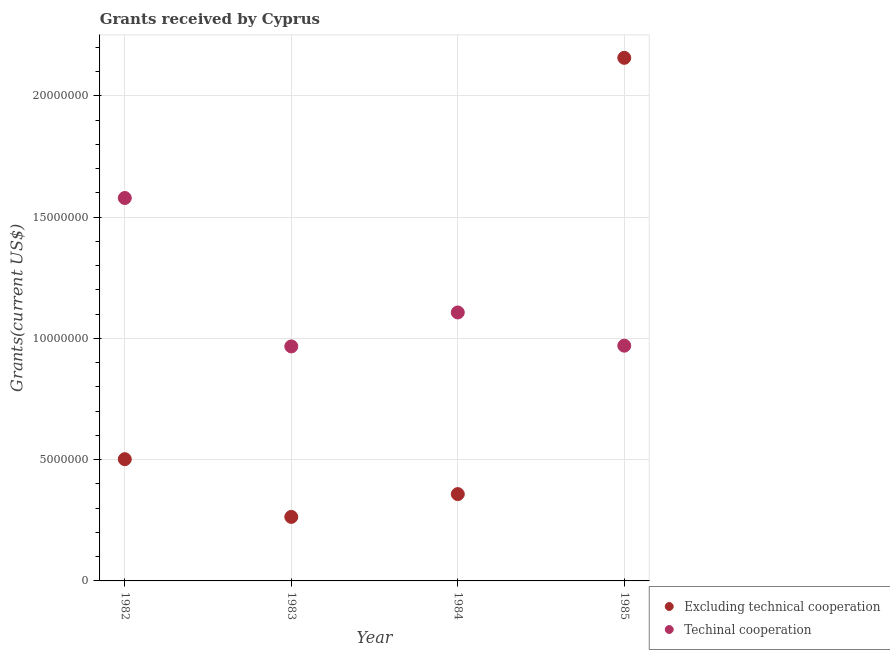What is the amount of grants received(excluding technical cooperation) in 1985?
Make the answer very short. 2.16e+07. Across all years, what is the maximum amount of grants received(excluding technical cooperation)?
Provide a succinct answer. 2.16e+07. Across all years, what is the minimum amount of grants received(including technical cooperation)?
Provide a succinct answer. 9.67e+06. In which year was the amount of grants received(excluding technical cooperation) minimum?
Provide a short and direct response. 1983. What is the total amount of grants received(including technical cooperation) in the graph?
Your response must be concise. 4.62e+07. What is the difference between the amount of grants received(excluding technical cooperation) in 1984 and that in 1985?
Ensure brevity in your answer.  -1.80e+07. What is the difference between the amount of grants received(including technical cooperation) in 1985 and the amount of grants received(excluding technical cooperation) in 1984?
Offer a very short reply. 6.12e+06. What is the average amount of grants received(excluding technical cooperation) per year?
Ensure brevity in your answer.  8.20e+06. In the year 1982, what is the difference between the amount of grants received(including technical cooperation) and amount of grants received(excluding technical cooperation)?
Your answer should be compact. 1.08e+07. In how many years, is the amount of grants received(excluding technical cooperation) greater than 14000000 US$?
Offer a very short reply. 1. What is the ratio of the amount of grants received(excluding technical cooperation) in 1983 to that in 1984?
Provide a short and direct response. 0.74. Is the amount of grants received(excluding technical cooperation) in 1982 less than that in 1984?
Your response must be concise. No. What is the difference between the highest and the second highest amount of grants received(excluding technical cooperation)?
Your response must be concise. 1.66e+07. What is the difference between the highest and the lowest amount of grants received(excluding technical cooperation)?
Give a very brief answer. 1.89e+07. In how many years, is the amount of grants received(excluding technical cooperation) greater than the average amount of grants received(excluding technical cooperation) taken over all years?
Your answer should be compact. 1. Is the sum of the amount of grants received(excluding technical cooperation) in 1982 and 1983 greater than the maximum amount of grants received(including technical cooperation) across all years?
Your answer should be compact. No. Does the amount of grants received(excluding technical cooperation) monotonically increase over the years?
Your answer should be very brief. No. Is the amount of grants received(excluding technical cooperation) strictly less than the amount of grants received(including technical cooperation) over the years?
Provide a succinct answer. No. How many dotlines are there?
Keep it short and to the point. 2. How many years are there in the graph?
Ensure brevity in your answer.  4. Are the values on the major ticks of Y-axis written in scientific E-notation?
Your answer should be compact. No. Where does the legend appear in the graph?
Offer a very short reply. Bottom right. How many legend labels are there?
Your response must be concise. 2. How are the legend labels stacked?
Ensure brevity in your answer.  Vertical. What is the title of the graph?
Make the answer very short. Grants received by Cyprus. Does "From production" appear as one of the legend labels in the graph?
Ensure brevity in your answer.  No. What is the label or title of the X-axis?
Make the answer very short. Year. What is the label or title of the Y-axis?
Make the answer very short. Grants(current US$). What is the Grants(current US$) in Excluding technical cooperation in 1982?
Keep it short and to the point. 5.02e+06. What is the Grants(current US$) in Techinal cooperation in 1982?
Give a very brief answer. 1.58e+07. What is the Grants(current US$) in Excluding technical cooperation in 1983?
Your response must be concise. 2.64e+06. What is the Grants(current US$) of Techinal cooperation in 1983?
Your response must be concise. 9.67e+06. What is the Grants(current US$) of Excluding technical cooperation in 1984?
Keep it short and to the point. 3.58e+06. What is the Grants(current US$) of Techinal cooperation in 1984?
Ensure brevity in your answer.  1.11e+07. What is the Grants(current US$) in Excluding technical cooperation in 1985?
Your answer should be very brief. 2.16e+07. What is the Grants(current US$) in Techinal cooperation in 1985?
Offer a very short reply. 9.70e+06. Across all years, what is the maximum Grants(current US$) in Excluding technical cooperation?
Provide a succinct answer. 2.16e+07. Across all years, what is the maximum Grants(current US$) of Techinal cooperation?
Provide a succinct answer. 1.58e+07. Across all years, what is the minimum Grants(current US$) of Excluding technical cooperation?
Your response must be concise. 2.64e+06. Across all years, what is the minimum Grants(current US$) of Techinal cooperation?
Give a very brief answer. 9.67e+06. What is the total Grants(current US$) of Excluding technical cooperation in the graph?
Your answer should be very brief. 3.28e+07. What is the total Grants(current US$) in Techinal cooperation in the graph?
Make the answer very short. 4.62e+07. What is the difference between the Grants(current US$) of Excluding technical cooperation in 1982 and that in 1983?
Provide a short and direct response. 2.38e+06. What is the difference between the Grants(current US$) of Techinal cooperation in 1982 and that in 1983?
Offer a terse response. 6.12e+06. What is the difference between the Grants(current US$) in Excluding technical cooperation in 1982 and that in 1984?
Your answer should be very brief. 1.44e+06. What is the difference between the Grants(current US$) in Techinal cooperation in 1982 and that in 1984?
Your response must be concise. 4.72e+06. What is the difference between the Grants(current US$) of Excluding technical cooperation in 1982 and that in 1985?
Ensure brevity in your answer.  -1.66e+07. What is the difference between the Grants(current US$) in Techinal cooperation in 1982 and that in 1985?
Your answer should be compact. 6.09e+06. What is the difference between the Grants(current US$) in Excluding technical cooperation in 1983 and that in 1984?
Offer a terse response. -9.40e+05. What is the difference between the Grants(current US$) in Techinal cooperation in 1983 and that in 1984?
Give a very brief answer. -1.40e+06. What is the difference between the Grants(current US$) of Excluding technical cooperation in 1983 and that in 1985?
Give a very brief answer. -1.89e+07. What is the difference between the Grants(current US$) of Excluding technical cooperation in 1984 and that in 1985?
Make the answer very short. -1.80e+07. What is the difference between the Grants(current US$) of Techinal cooperation in 1984 and that in 1985?
Keep it short and to the point. 1.37e+06. What is the difference between the Grants(current US$) of Excluding technical cooperation in 1982 and the Grants(current US$) of Techinal cooperation in 1983?
Offer a terse response. -4.65e+06. What is the difference between the Grants(current US$) in Excluding technical cooperation in 1982 and the Grants(current US$) in Techinal cooperation in 1984?
Your response must be concise. -6.05e+06. What is the difference between the Grants(current US$) of Excluding technical cooperation in 1982 and the Grants(current US$) of Techinal cooperation in 1985?
Offer a terse response. -4.68e+06. What is the difference between the Grants(current US$) of Excluding technical cooperation in 1983 and the Grants(current US$) of Techinal cooperation in 1984?
Keep it short and to the point. -8.43e+06. What is the difference between the Grants(current US$) in Excluding technical cooperation in 1983 and the Grants(current US$) in Techinal cooperation in 1985?
Make the answer very short. -7.06e+06. What is the difference between the Grants(current US$) of Excluding technical cooperation in 1984 and the Grants(current US$) of Techinal cooperation in 1985?
Your answer should be very brief. -6.12e+06. What is the average Grants(current US$) in Excluding technical cooperation per year?
Your answer should be compact. 8.20e+06. What is the average Grants(current US$) of Techinal cooperation per year?
Keep it short and to the point. 1.16e+07. In the year 1982, what is the difference between the Grants(current US$) of Excluding technical cooperation and Grants(current US$) of Techinal cooperation?
Provide a short and direct response. -1.08e+07. In the year 1983, what is the difference between the Grants(current US$) of Excluding technical cooperation and Grants(current US$) of Techinal cooperation?
Provide a succinct answer. -7.03e+06. In the year 1984, what is the difference between the Grants(current US$) of Excluding technical cooperation and Grants(current US$) of Techinal cooperation?
Provide a short and direct response. -7.49e+06. In the year 1985, what is the difference between the Grants(current US$) of Excluding technical cooperation and Grants(current US$) of Techinal cooperation?
Offer a terse response. 1.19e+07. What is the ratio of the Grants(current US$) of Excluding technical cooperation in 1982 to that in 1983?
Your response must be concise. 1.9. What is the ratio of the Grants(current US$) in Techinal cooperation in 1982 to that in 1983?
Offer a very short reply. 1.63. What is the ratio of the Grants(current US$) of Excluding technical cooperation in 1982 to that in 1984?
Your answer should be compact. 1.4. What is the ratio of the Grants(current US$) of Techinal cooperation in 1982 to that in 1984?
Your answer should be very brief. 1.43. What is the ratio of the Grants(current US$) of Excluding technical cooperation in 1982 to that in 1985?
Provide a short and direct response. 0.23. What is the ratio of the Grants(current US$) of Techinal cooperation in 1982 to that in 1985?
Offer a very short reply. 1.63. What is the ratio of the Grants(current US$) in Excluding technical cooperation in 1983 to that in 1984?
Ensure brevity in your answer.  0.74. What is the ratio of the Grants(current US$) in Techinal cooperation in 1983 to that in 1984?
Ensure brevity in your answer.  0.87. What is the ratio of the Grants(current US$) in Excluding technical cooperation in 1983 to that in 1985?
Keep it short and to the point. 0.12. What is the ratio of the Grants(current US$) of Techinal cooperation in 1983 to that in 1985?
Offer a terse response. 1. What is the ratio of the Grants(current US$) in Excluding technical cooperation in 1984 to that in 1985?
Make the answer very short. 0.17. What is the ratio of the Grants(current US$) in Techinal cooperation in 1984 to that in 1985?
Offer a very short reply. 1.14. What is the difference between the highest and the second highest Grants(current US$) of Excluding technical cooperation?
Your answer should be very brief. 1.66e+07. What is the difference between the highest and the second highest Grants(current US$) in Techinal cooperation?
Offer a terse response. 4.72e+06. What is the difference between the highest and the lowest Grants(current US$) of Excluding technical cooperation?
Keep it short and to the point. 1.89e+07. What is the difference between the highest and the lowest Grants(current US$) of Techinal cooperation?
Make the answer very short. 6.12e+06. 